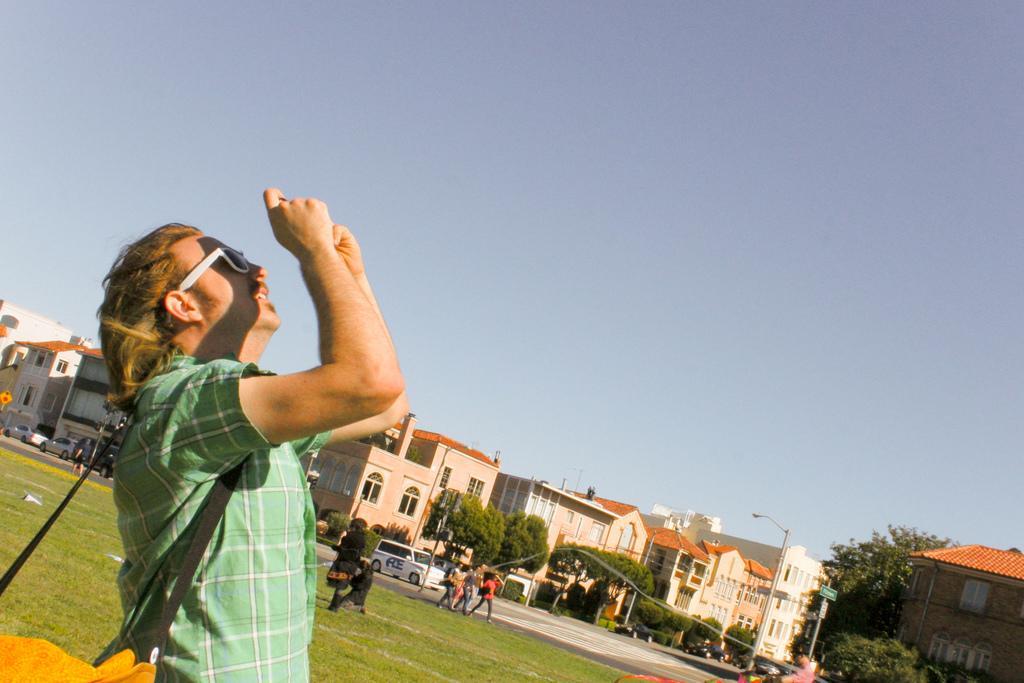Can you describe this image briefly? In this image we can see a man standing. He is wearing a bag. In the background there are buildings, trees, poles and sky. In the center there are people and cars on the road. 